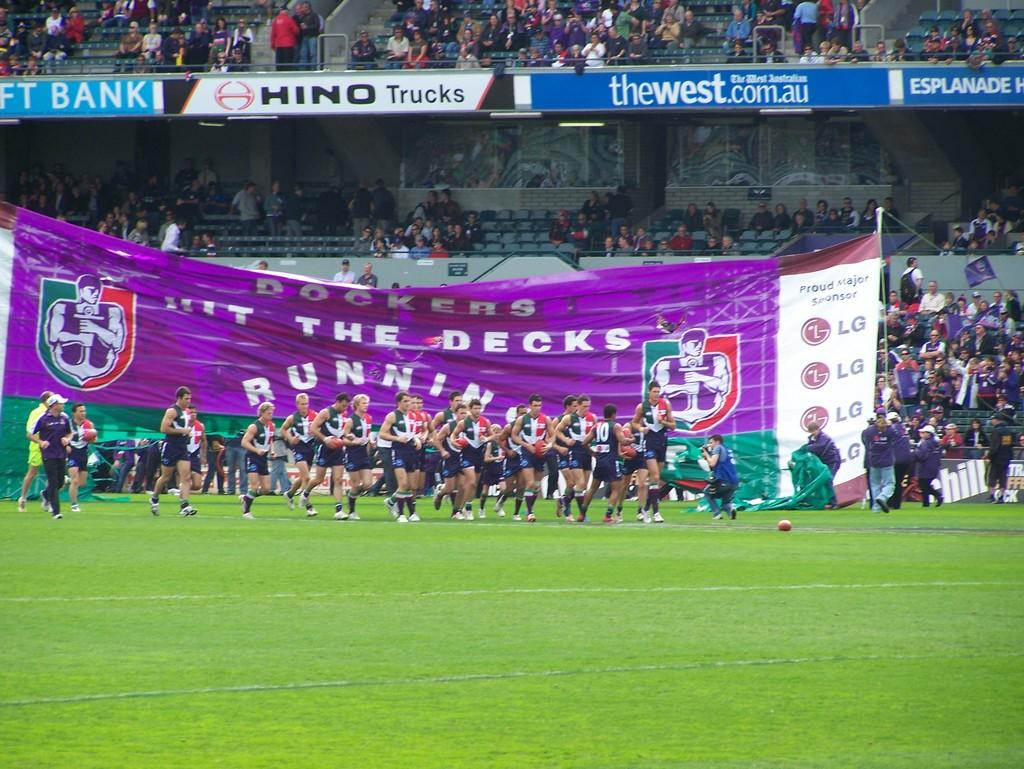<image>
Create a compact narrative representing the image presented. A rugby team enters the field while fans hold up a hit the decks running banner. 